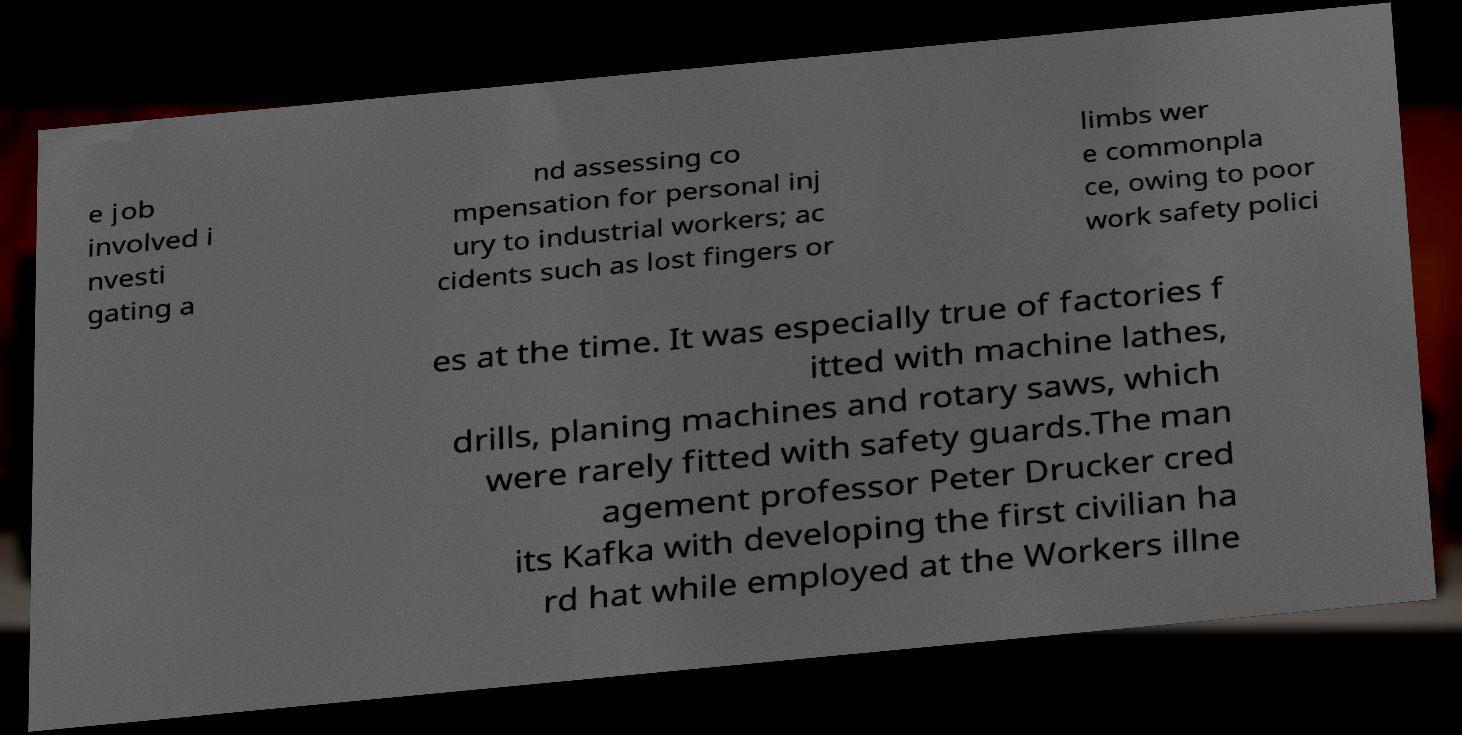Could you assist in decoding the text presented in this image and type it out clearly? e job involved i nvesti gating a nd assessing co mpensation for personal inj ury to industrial workers; ac cidents such as lost fingers or limbs wer e commonpla ce, owing to poor work safety polici es at the time. It was especially true of factories f itted with machine lathes, drills, planing machines and rotary saws, which were rarely fitted with safety guards.The man agement professor Peter Drucker cred its Kafka with developing the first civilian ha rd hat while employed at the Workers illne 